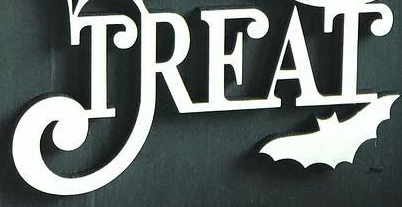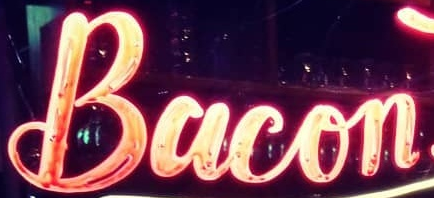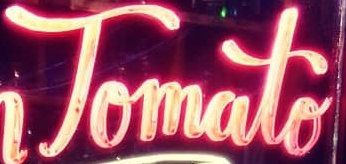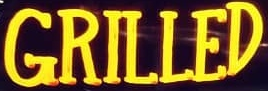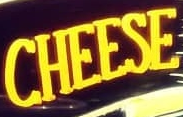What text is displayed in these images sequentially, separated by a semicolon? TREAT; Bacon; Tomato; GRILLED; CHEESE 